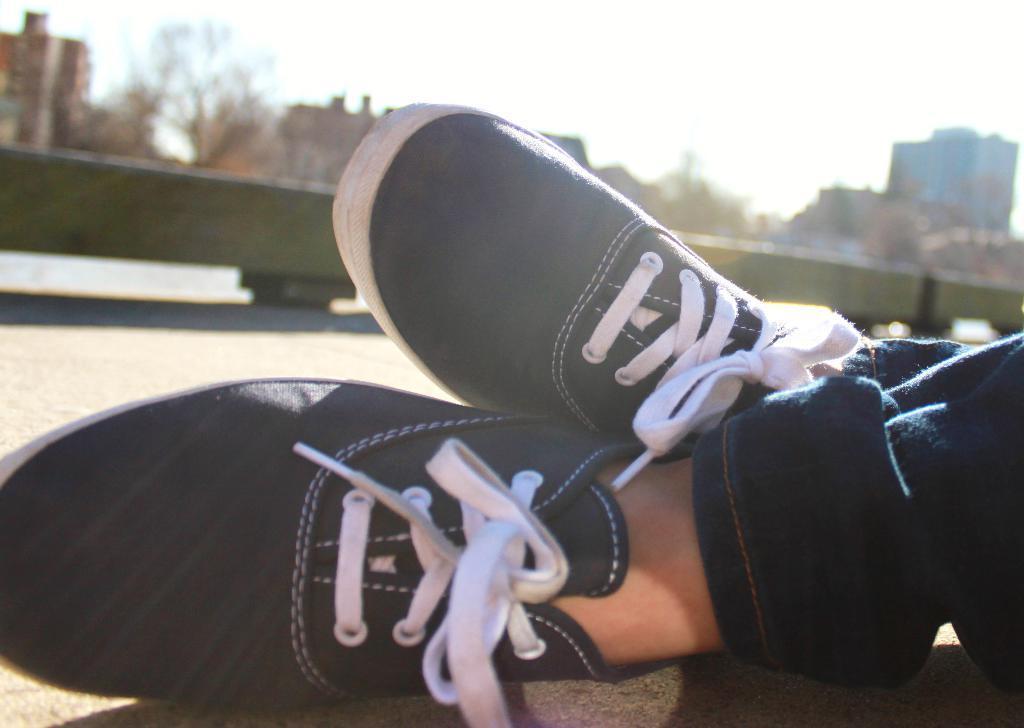Describe this image in one or two sentences. In front of the picture, we see a person is wearing the blue jeans and the blue and white shoes. Behind that, we see the railing of a train in green color. There are trees and buildings in the background. At the top, we see the sky. This picture is blurred in the background. 